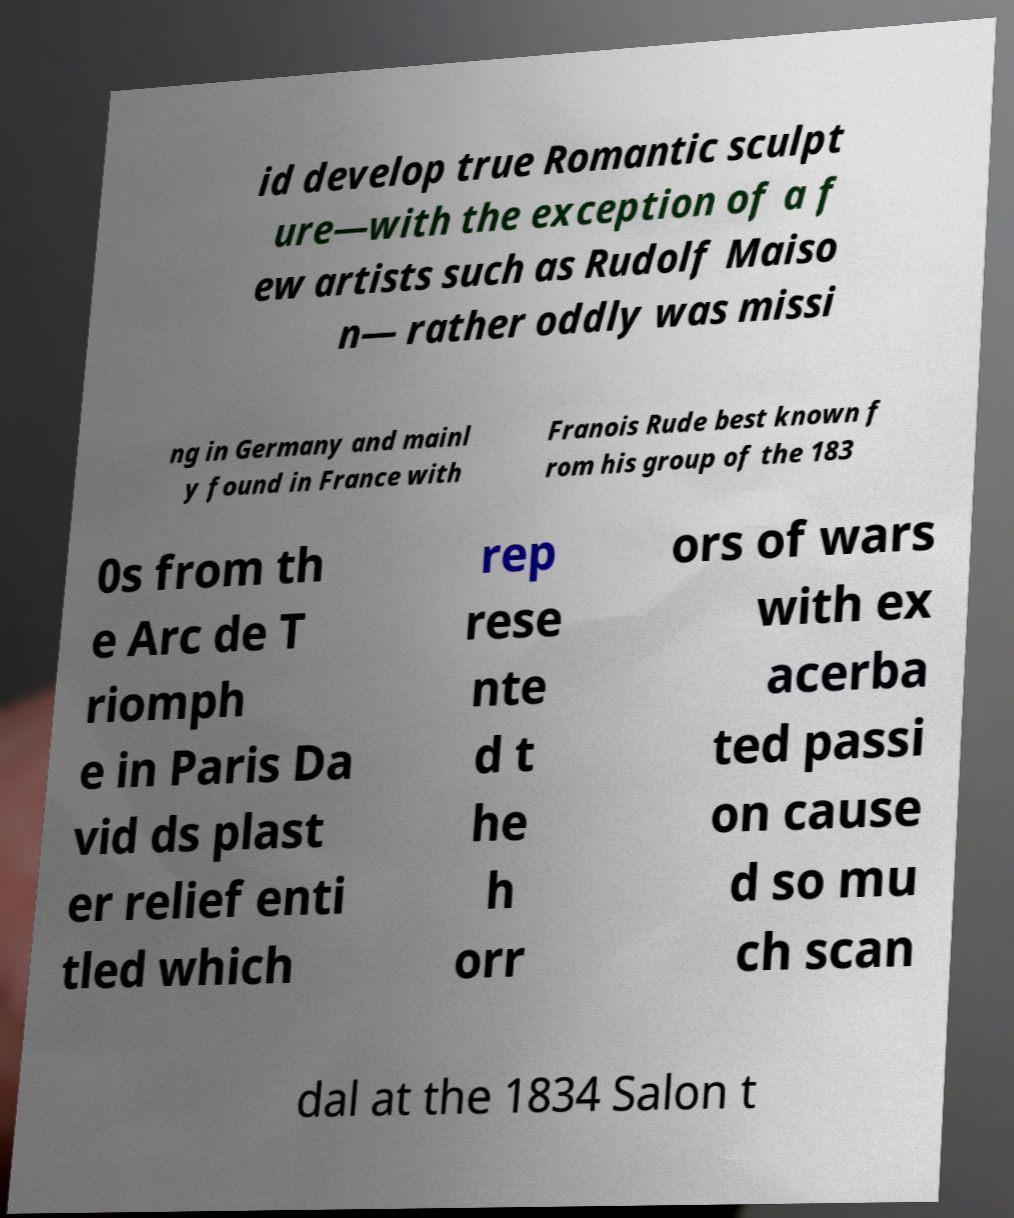Could you extract and type out the text from this image? id develop true Romantic sculpt ure—with the exception of a f ew artists such as Rudolf Maiso n— rather oddly was missi ng in Germany and mainl y found in France with Franois Rude best known f rom his group of the 183 0s from th e Arc de T riomph e in Paris Da vid ds plast er relief enti tled which rep rese nte d t he h orr ors of wars with ex acerba ted passi on cause d so mu ch scan dal at the 1834 Salon t 